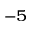<formula> <loc_0><loc_0><loc_500><loc_500>^ { - 5 }</formula> 